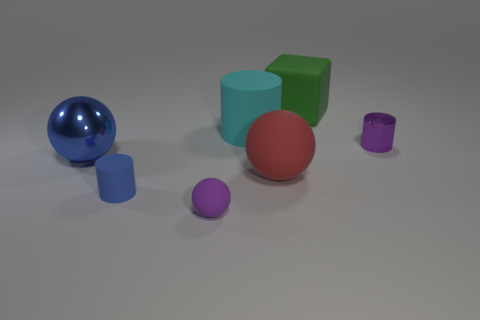Is there a green cube made of the same material as the purple cylinder?
Keep it short and to the point. No. What number of things are both behind the big blue ball and in front of the green object?
Provide a succinct answer. 2. There is a tiny cylinder behind the large red matte object; what material is it?
Your response must be concise. Metal. What is the size of the cyan cylinder that is made of the same material as the green cube?
Make the answer very short. Large. Are there any large metallic balls on the left side of the big rubber block?
Ensure brevity in your answer.  Yes. What is the size of the red thing that is the same shape as the large blue object?
Provide a succinct answer. Large. Do the big metallic ball and the small cylinder that is on the right side of the big green block have the same color?
Keep it short and to the point. No. Do the big rubber block and the metallic cylinder have the same color?
Offer a terse response. No. Is the number of blue objects less than the number of tiny blue matte cylinders?
Your answer should be compact. No. What number of other things are the same color as the small metal thing?
Provide a succinct answer. 1. 